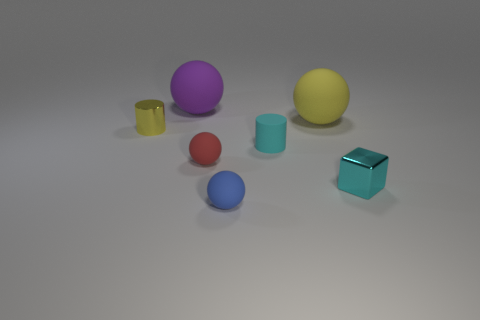There is a large object on the left side of the cyan matte thing; how many large rubber balls are to the right of it?
Offer a very short reply. 1. Is the material of the red ball the same as the large yellow ball?
Offer a terse response. Yes. There is a cylinder that is the same color as the cube; what is its size?
Keep it short and to the point. Small. Are there any other big balls made of the same material as the blue ball?
Offer a very short reply. Yes. What color is the large thing that is behind the yellow rubber thing that is left of the small metal thing to the right of the cyan rubber object?
Your answer should be very brief. Purple. What number of brown objects are shiny cylinders or cylinders?
Offer a very short reply. 0. How many red objects are the same shape as the small blue thing?
Provide a succinct answer. 1. The cyan metallic thing that is the same size as the red rubber thing is what shape?
Keep it short and to the point. Cube. There is a large purple thing; are there any large matte spheres in front of it?
Your answer should be very brief. Yes. Are there any small cylinders that are to the right of the cylinder that is behind the matte cylinder?
Your answer should be very brief. Yes. 